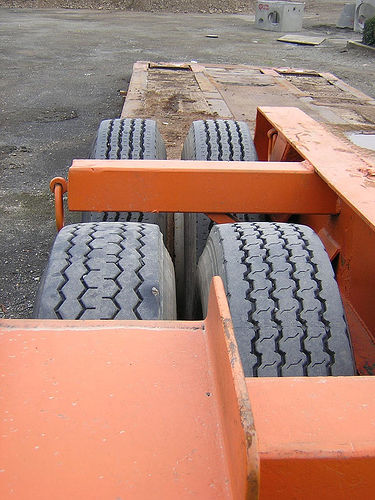<image>
Is there a tire to the left of the tire? No. The tire is not to the left of the tire. From this viewpoint, they have a different horizontal relationship. 